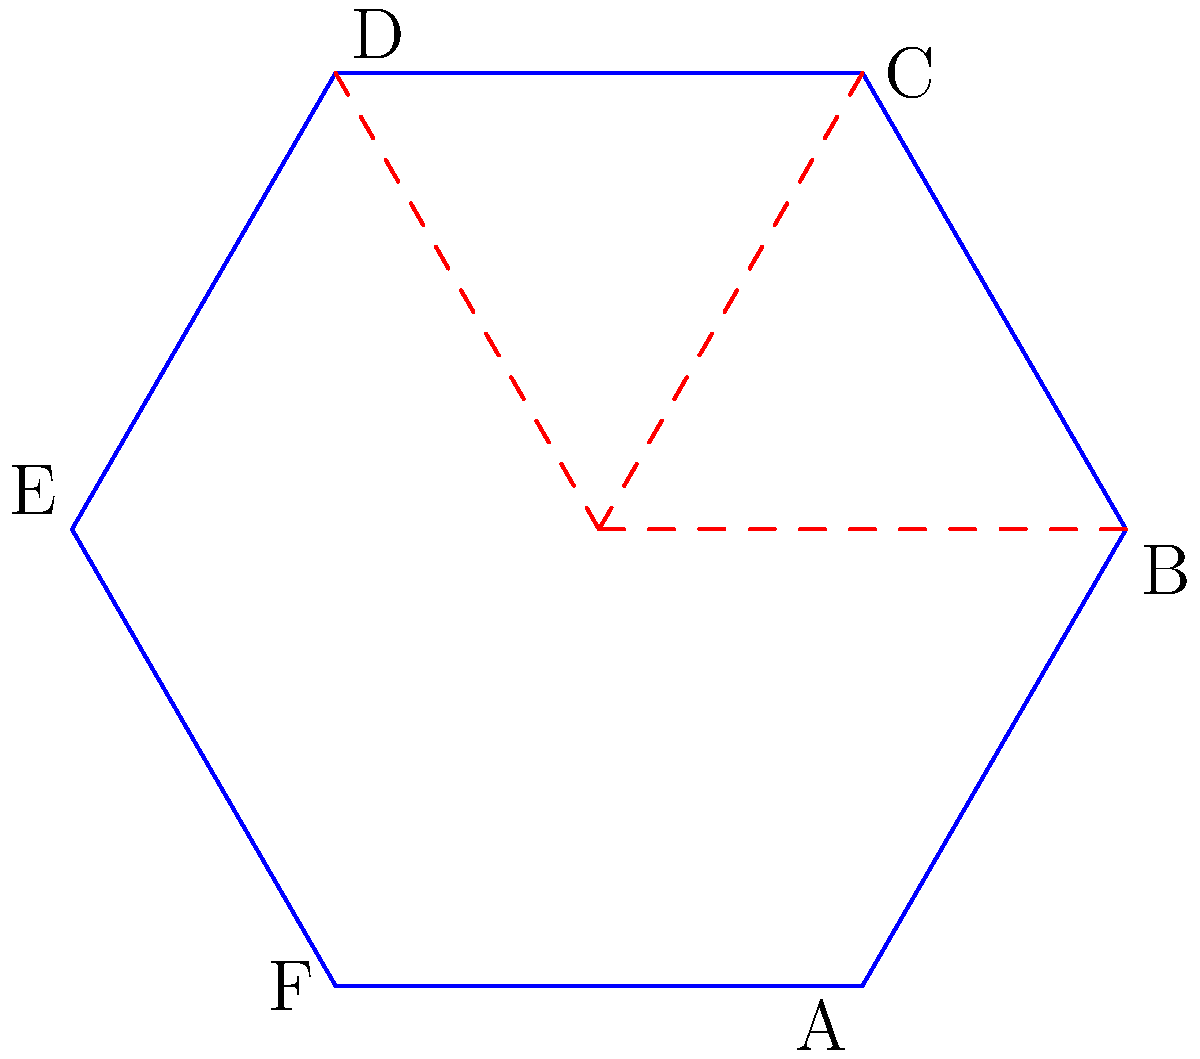During a camping trip, you find a hexagonal tent that needs to be assembled. The diagram shows the flat layout of the tent with dashed lines indicating where it should be folded. If you fold along these lines and bring points A, C, and E together, what shape will the assembled tent form when viewed from above? Let's break this down step-by-step:

1. The tent starts as a regular hexagon with six equal sides.

2. There are three fold lines (dashed red lines) that divide the hexagon into six equal triangles.

3. We're instructed to fold the tent so that points A, C, and E meet at one point. This means:
   - Side AB will fold towards side BC
   - Side CD will fold towards side DE
   - Side EF will fold towards side FA

4. When these folds are made, the hexagon will be divided into two halves:
   - One half consists of triangles ABC, CDE, and EFA
   - The other half consists of triangles BCD, DEF, and FAB

5. These two halves will form a three-dimensional shape where:
   - The bottom remains a hexagon (BCDFAB)
   - The top comes to a point where A, C, and E meet

6. When viewed from above, this shape will appear as an equilateral triangle, with vertices at points B, D, and F.

Therefore, the assembled tent, when viewed from above, will form an equilateral triangle.
Answer: Equilateral triangle 